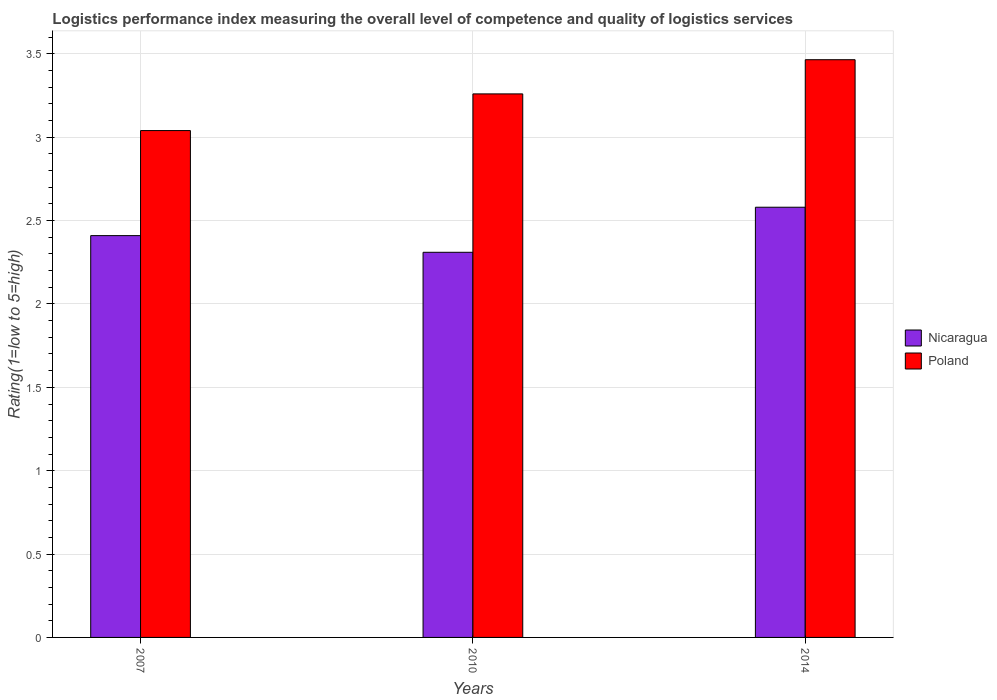How many different coloured bars are there?
Your answer should be very brief. 2. How many groups of bars are there?
Your answer should be very brief. 3. Are the number of bars per tick equal to the number of legend labels?
Your answer should be very brief. Yes. Are the number of bars on each tick of the X-axis equal?
Offer a very short reply. Yes. What is the label of the 3rd group of bars from the left?
Ensure brevity in your answer.  2014. In how many cases, is the number of bars for a given year not equal to the number of legend labels?
Give a very brief answer. 0. What is the Logistic performance index in Poland in 2010?
Give a very brief answer. 3.26. Across all years, what is the maximum Logistic performance index in Poland?
Your answer should be very brief. 3.47. Across all years, what is the minimum Logistic performance index in Nicaragua?
Provide a short and direct response. 2.31. In which year was the Logistic performance index in Poland maximum?
Give a very brief answer. 2014. What is the total Logistic performance index in Nicaragua in the graph?
Make the answer very short. 7.3. What is the difference between the Logistic performance index in Nicaragua in 2010 and that in 2014?
Ensure brevity in your answer.  -0.27. What is the difference between the Logistic performance index in Nicaragua in 2010 and the Logistic performance index in Poland in 2014?
Ensure brevity in your answer.  -1.16. What is the average Logistic performance index in Nicaragua per year?
Your answer should be compact. 2.43. In the year 2007, what is the difference between the Logistic performance index in Poland and Logistic performance index in Nicaragua?
Your response must be concise. 0.63. What is the ratio of the Logistic performance index in Poland in 2007 to that in 2010?
Your answer should be compact. 0.93. What is the difference between the highest and the second highest Logistic performance index in Poland?
Your response must be concise. 0.21. What is the difference between the highest and the lowest Logistic performance index in Poland?
Keep it short and to the point. 0.43. Is the sum of the Logistic performance index in Poland in 2007 and 2014 greater than the maximum Logistic performance index in Nicaragua across all years?
Your answer should be compact. Yes. What does the 1st bar from the left in 2010 represents?
Your answer should be compact. Nicaragua. How many bars are there?
Keep it short and to the point. 6. Are all the bars in the graph horizontal?
Make the answer very short. No. How many years are there in the graph?
Your response must be concise. 3. Are the values on the major ticks of Y-axis written in scientific E-notation?
Provide a short and direct response. No. Does the graph contain grids?
Provide a short and direct response. Yes. Where does the legend appear in the graph?
Keep it short and to the point. Center right. What is the title of the graph?
Your answer should be compact. Logistics performance index measuring the overall level of competence and quality of logistics services. What is the label or title of the Y-axis?
Your answer should be compact. Rating(1=low to 5=high). What is the Rating(1=low to 5=high) of Nicaragua in 2007?
Provide a succinct answer. 2.41. What is the Rating(1=low to 5=high) in Poland in 2007?
Make the answer very short. 3.04. What is the Rating(1=low to 5=high) of Nicaragua in 2010?
Ensure brevity in your answer.  2.31. What is the Rating(1=low to 5=high) in Poland in 2010?
Provide a succinct answer. 3.26. What is the Rating(1=low to 5=high) of Nicaragua in 2014?
Offer a terse response. 2.58. What is the Rating(1=low to 5=high) of Poland in 2014?
Make the answer very short. 3.47. Across all years, what is the maximum Rating(1=low to 5=high) in Nicaragua?
Make the answer very short. 2.58. Across all years, what is the maximum Rating(1=low to 5=high) of Poland?
Provide a succinct answer. 3.47. Across all years, what is the minimum Rating(1=low to 5=high) in Nicaragua?
Ensure brevity in your answer.  2.31. Across all years, what is the minimum Rating(1=low to 5=high) in Poland?
Ensure brevity in your answer.  3.04. What is the total Rating(1=low to 5=high) in Nicaragua in the graph?
Provide a succinct answer. 7.3. What is the total Rating(1=low to 5=high) in Poland in the graph?
Your response must be concise. 9.77. What is the difference between the Rating(1=low to 5=high) of Nicaragua in 2007 and that in 2010?
Provide a short and direct response. 0.1. What is the difference between the Rating(1=low to 5=high) in Poland in 2007 and that in 2010?
Provide a short and direct response. -0.22. What is the difference between the Rating(1=low to 5=high) of Nicaragua in 2007 and that in 2014?
Give a very brief answer. -0.17. What is the difference between the Rating(1=low to 5=high) in Poland in 2007 and that in 2014?
Your response must be concise. -0.42. What is the difference between the Rating(1=low to 5=high) in Nicaragua in 2010 and that in 2014?
Ensure brevity in your answer.  -0.27. What is the difference between the Rating(1=low to 5=high) in Poland in 2010 and that in 2014?
Your answer should be very brief. -0.2. What is the difference between the Rating(1=low to 5=high) in Nicaragua in 2007 and the Rating(1=low to 5=high) in Poland in 2010?
Ensure brevity in your answer.  -0.85. What is the difference between the Rating(1=low to 5=high) of Nicaragua in 2007 and the Rating(1=low to 5=high) of Poland in 2014?
Ensure brevity in your answer.  -1.05. What is the difference between the Rating(1=low to 5=high) in Nicaragua in 2010 and the Rating(1=low to 5=high) in Poland in 2014?
Ensure brevity in your answer.  -1.16. What is the average Rating(1=low to 5=high) of Nicaragua per year?
Offer a very short reply. 2.43. What is the average Rating(1=low to 5=high) in Poland per year?
Keep it short and to the point. 3.25. In the year 2007, what is the difference between the Rating(1=low to 5=high) of Nicaragua and Rating(1=low to 5=high) of Poland?
Your answer should be compact. -0.63. In the year 2010, what is the difference between the Rating(1=low to 5=high) of Nicaragua and Rating(1=low to 5=high) of Poland?
Provide a succinct answer. -0.95. In the year 2014, what is the difference between the Rating(1=low to 5=high) in Nicaragua and Rating(1=low to 5=high) in Poland?
Ensure brevity in your answer.  -0.88. What is the ratio of the Rating(1=low to 5=high) of Nicaragua in 2007 to that in 2010?
Give a very brief answer. 1.04. What is the ratio of the Rating(1=low to 5=high) of Poland in 2007 to that in 2010?
Make the answer very short. 0.93. What is the ratio of the Rating(1=low to 5=high) of Nicaragua in 2007 to that in 2014?
Give a very brief answer. 0.93. What is the ratio of the Rating(1=low to 5=high) of Poland in 2007 to that in 2014?
Ensure brevity in your answer.  0.88. What is the ratio of the Rating(1=low to 5=high) in Nicaragua in 2010 to that in 2014?
Give a very brief answer. 0.9. What is the ratio of the Rating(1=low to 5=high) in Poland in 2010 to that in 2014?
Provide a succinct answer. 0.94. What is the difference between the highest and the second highest Rating(1=low to 5=high) of Nicaragua?
Ensure brevity in your answer.  0.17. What is the difference between the highest and the second highest Rating(1=low to 5=high) of Poland?
Give a very brief answer. 0.2. What is the difference between the highest and the lowest Rating(1=low to 5=high) of Nicaragua?
Give a very brief answer. 0.27. What is the difference between the highest and the lowest Rating(1=low to 5=high) of Poland?
Offer a very short reply. 0.42. 